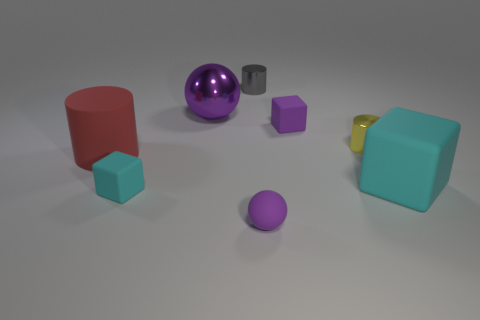There is a cyan cube that is the same size as the gray object; what is its material?
Provide a short and direct response. Rubber. There is another small object that is the same shape as the yellow object; what is its material?
Ensure brevity in your answer.  Metal. How many cylinders are either big rubber things or large metal objects?
Ensure brevity in your answer.  1. Is the size of the cyan cube that is to the right of the small cyan thing the same as the cyan cube that is to the left of the large rubber block?
Offer a very short reply. No. The cylinder behind the yellow metallic cylinder in front of the gray cylinder is made of what material?
Keep it short and to the point. Metal. Is the number of red objects to the right of the yellow cylinder less than the number of small gray balls?
Your answer should be compact. No. What is the shape of the purple thing that is the same material as the small purple block?
Provide a short and direct response. Sphere. How many other objects are the same shape as the big purple metal object?
Your answer should be very brief. 1. How many purple things are small rubber balls or metal cylinders?
Keep it short and to the point. 1. Is the shape of the big cyan thing the same as the tiny cyan rubber object?
Offer a very short reply. Yes. 